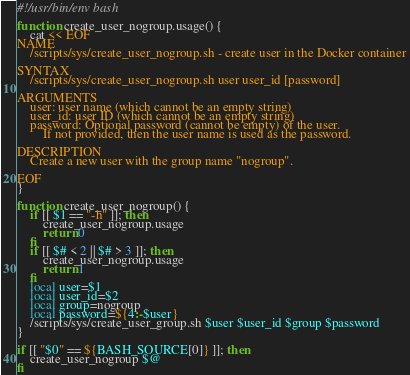<code> <loc_0><loc_0><loc_500><loc_500><_Bash_>#!/usr/bin/env bash

function create_user_nogroup.usage() {
    cat << EOF
NAME
    /scripts/sys/create_user_nogroup.sh - create user in the Docker container

SYNTAX 
    /scripts/sys/create_user_nogroup.sh user user_id [password] 

ARGUMENTS
    user: user name (which cannot be an empty string)
    user_id: user ID (which cannot be an empty string)
    password: Optional password (cannot be empty) of the user. 
        If not provided, then the user name is used as the password.

DESCRIPTION
    Create a new user with the group name "nogroup".

EOF
}

function create_user_nogroup() {
    if [[ $1 == "-h" ]]; then
        create_user_nogroup.usage
        return 0
    fi
    if [[ $# < 2 || $# > 3 ]]; then
        create_user_nogroup.usage
        return 1
    fi
    local user=$1
    local user_id=$2
    local group=nogroup
    local password=${4:-$user}
    /scripts/sys/create_user_group.sh $user $user_id $group $password
}

if [[ "$0" == ${BASH_SOURCE[0]} ]]; then
    create_user_nogroup $@
fi
</code> 